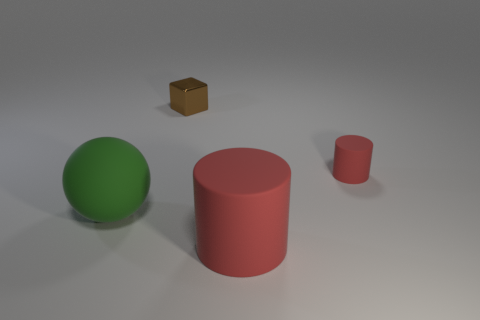Is the large green object made of the same material as the brown cube?
Offer a terse response. No. What number of gray objects are matte cylinders or things?
Provide a short and direct response. 0. Is the number of large green matte balls that are to the right of the brown thing greater than the number of cubes?
Make the answer very short. No. Is there a tiny shiny cube that has the same color as the tiny cylinder?
Offer a very short reply. No. What is the size of the green ball?
Provide a short and direct response. Large. Does the small metal block have the same color as the ball?
Offer a very short reply. No. What number of things are either small blue matte balls or red rubber cylinders in front of the ball?
Offer a very short reply. 1. There is a brown shiny object that is behind the red thing behind the large green matte object; how many large red matte cylinders are in front of it?
Provide a short and direct response. 1. There is a large thing that is the same color as the small rubber cylinder; what is it made of?
Provide a short and direct response. Rubber. What number of big purple blocks are there?
Make the answer very short. 0. 